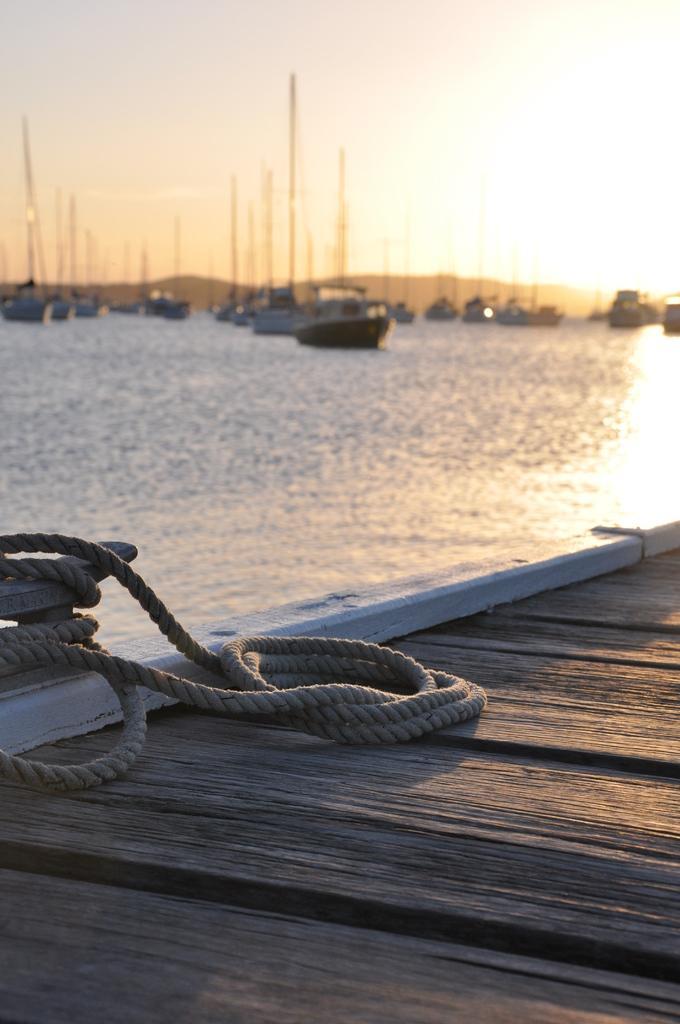Describe this image in one or two sentences. In this image in the foreground there is one board, on the board there is one rope and in the background there is a sea. In the sea there are some boats, and in the background there are some mountains. 